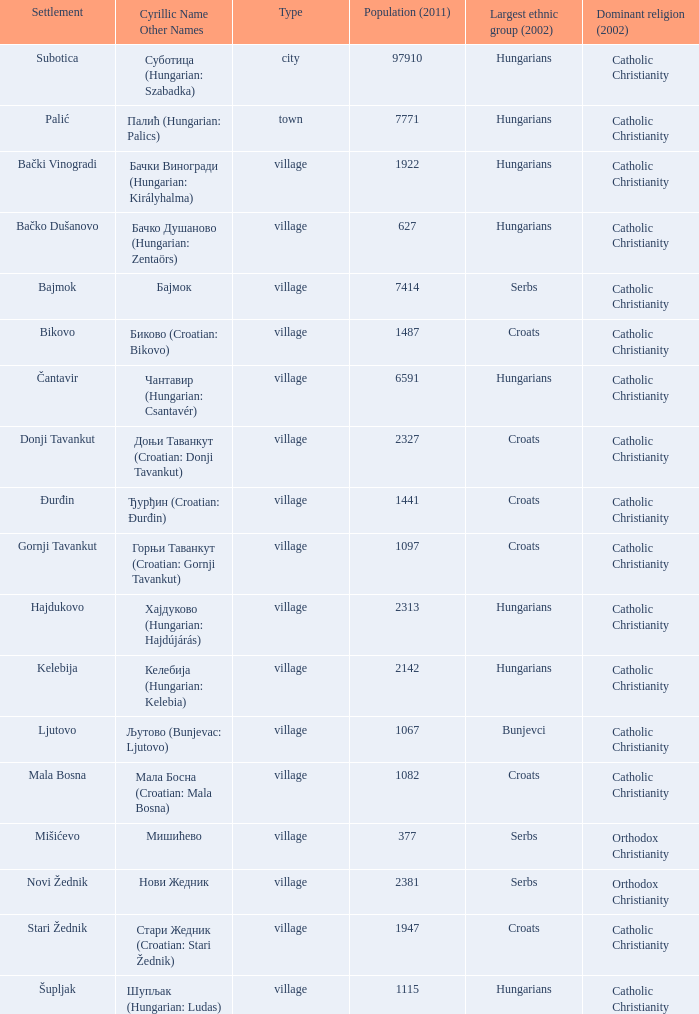What is the population in стари жедник (croatian: stari žednik)? 1947.0. 